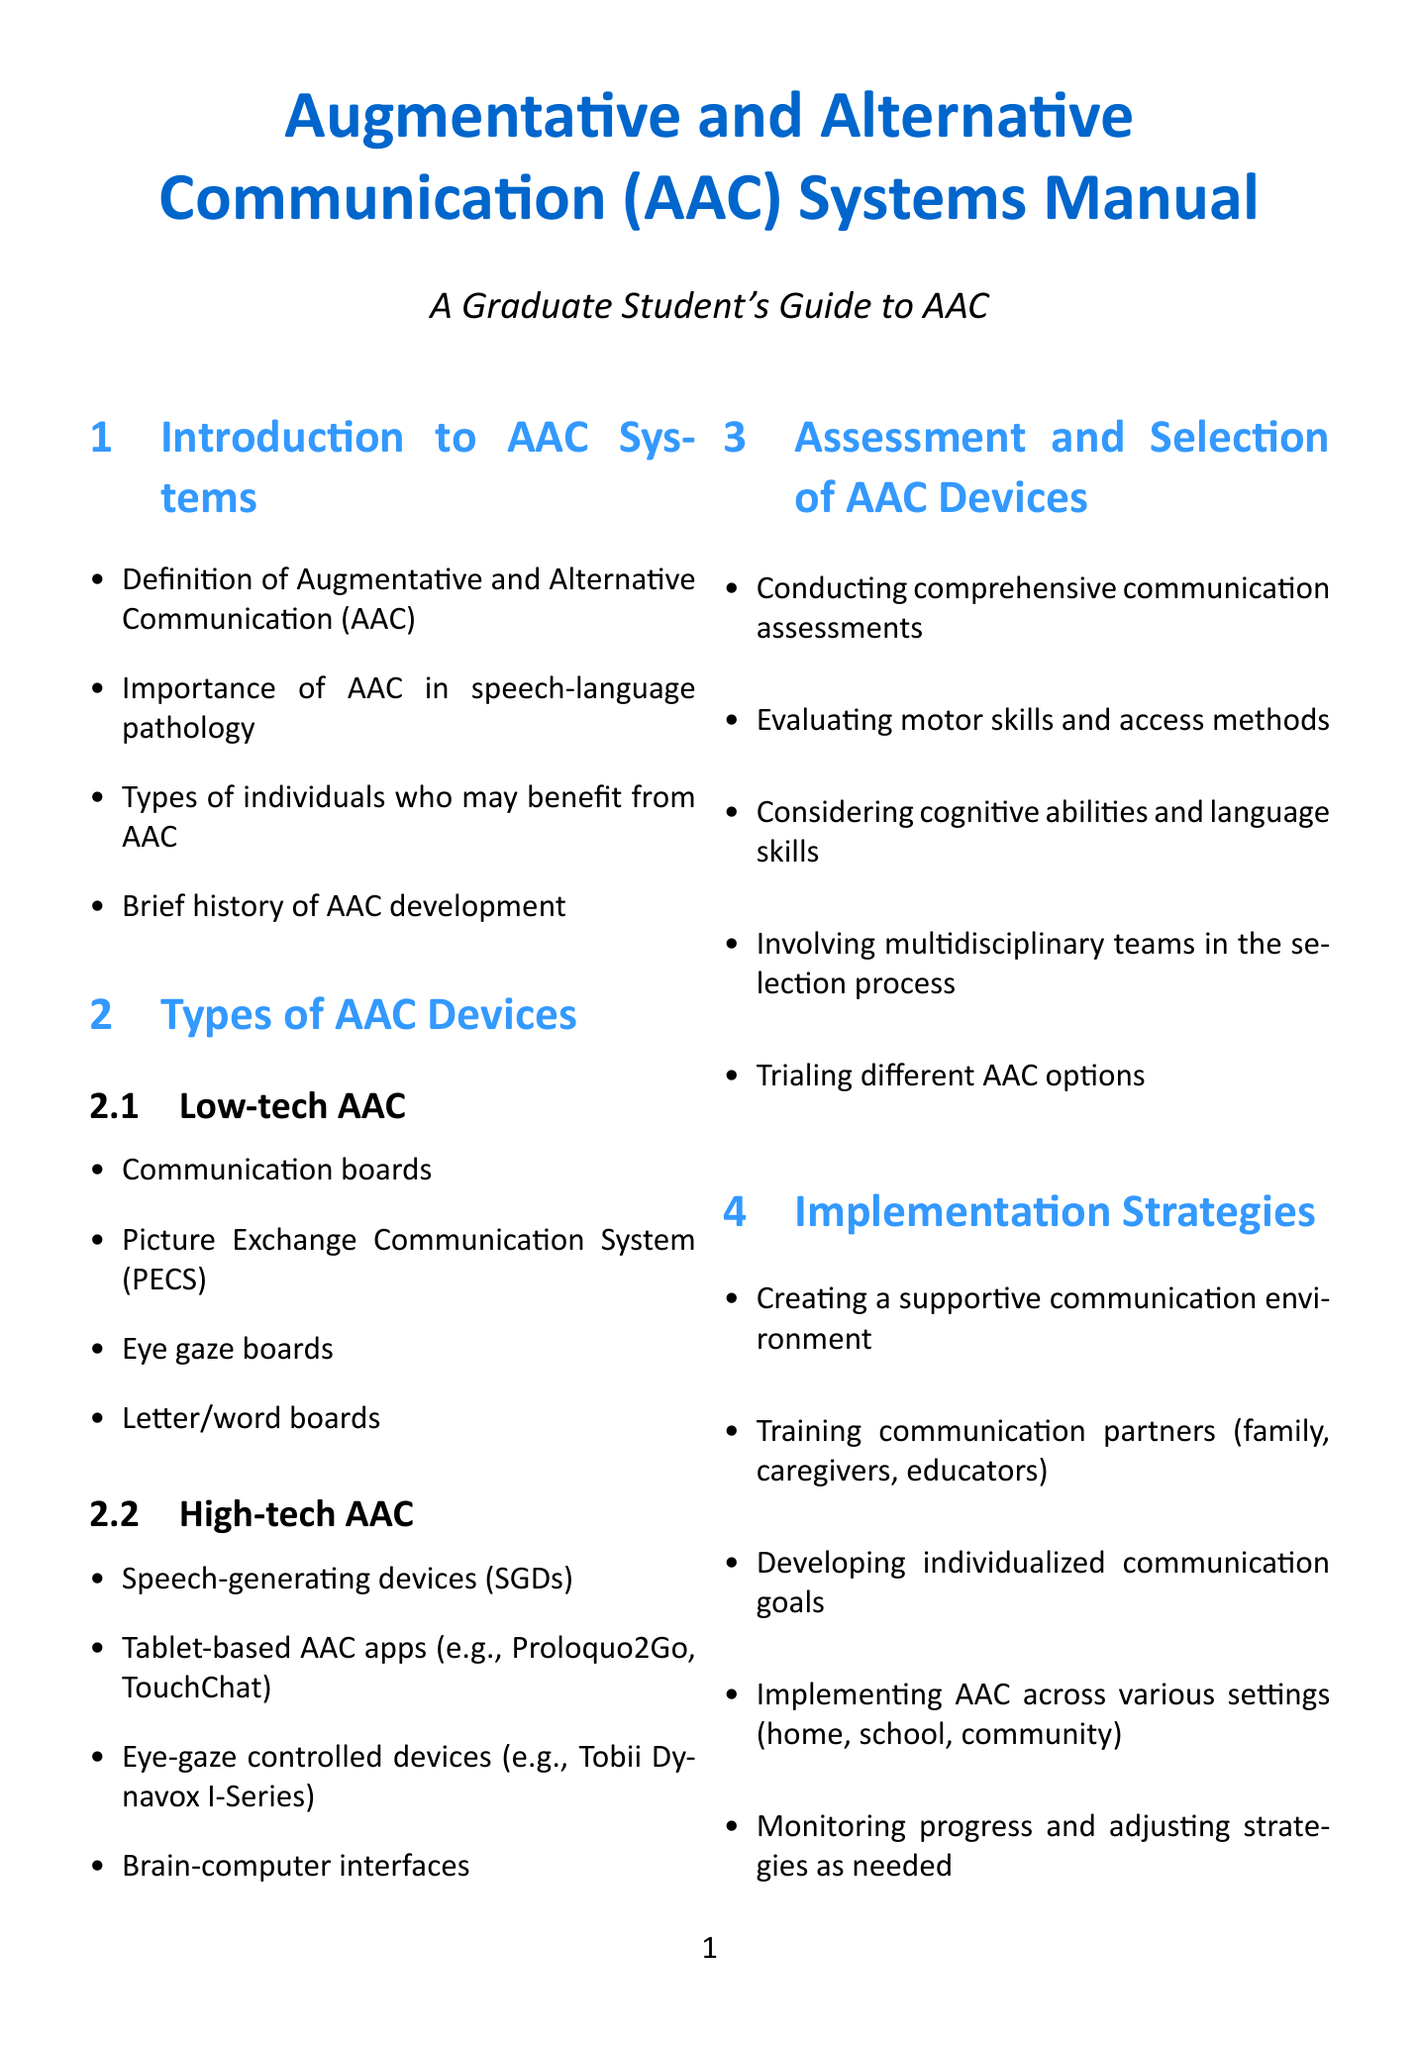What is the definition of AAC? The definition of Augmentative and Alternative Communication (AAC) is mentioned in the "Introduction to AAC Systems."
Answer: Augmentative and Alternative Communication (AAC) What are two examples of high-tech AAC devices? The "Types of AAC Devices" section lists examples of high-tech AAC devices, including "Speech-generating devices" and "Tablet-based AAC apps."
Answer: Speech-generating devices, Tablet-based AAC apps Which age group is included in a case study in the document? The "Case Studies" section references a case involving a "5-year-old with autism spectrum disorder."
Answer: 5-year-old What is one of the key strategies for AAC implementation? The "Implementation Strategies" section outlines several strategies, one of which is "Creating a supportive communication environment."
Answer: Creating a supportive communication environment What are the two types of AAC mentioned? The "Types of AAC Devices" section categorizes devices into "Low-tech AAC" and "High-tech AAC."
Answer: Low-tech AAC, High-tech AAC How does AAC support language development? The "AAC and Language Development" section describes several roles of AAC in language development, including "Supporting language acquisition through AAC."
Answer: Supporting language acquisition through AAC Which organization is mentioned for further reading on AAC? The "Resources and Further Reading" section includes professional organizations such as "ASHA."
Answer: ASHA What is a trend in AAC discussed in the manual? The "Emerging Trends in AAC" section investigates various trends, including "Artificial intelligence and machine learning in AAC."
Answer: Artificial intelligence and machine learning in AAC 